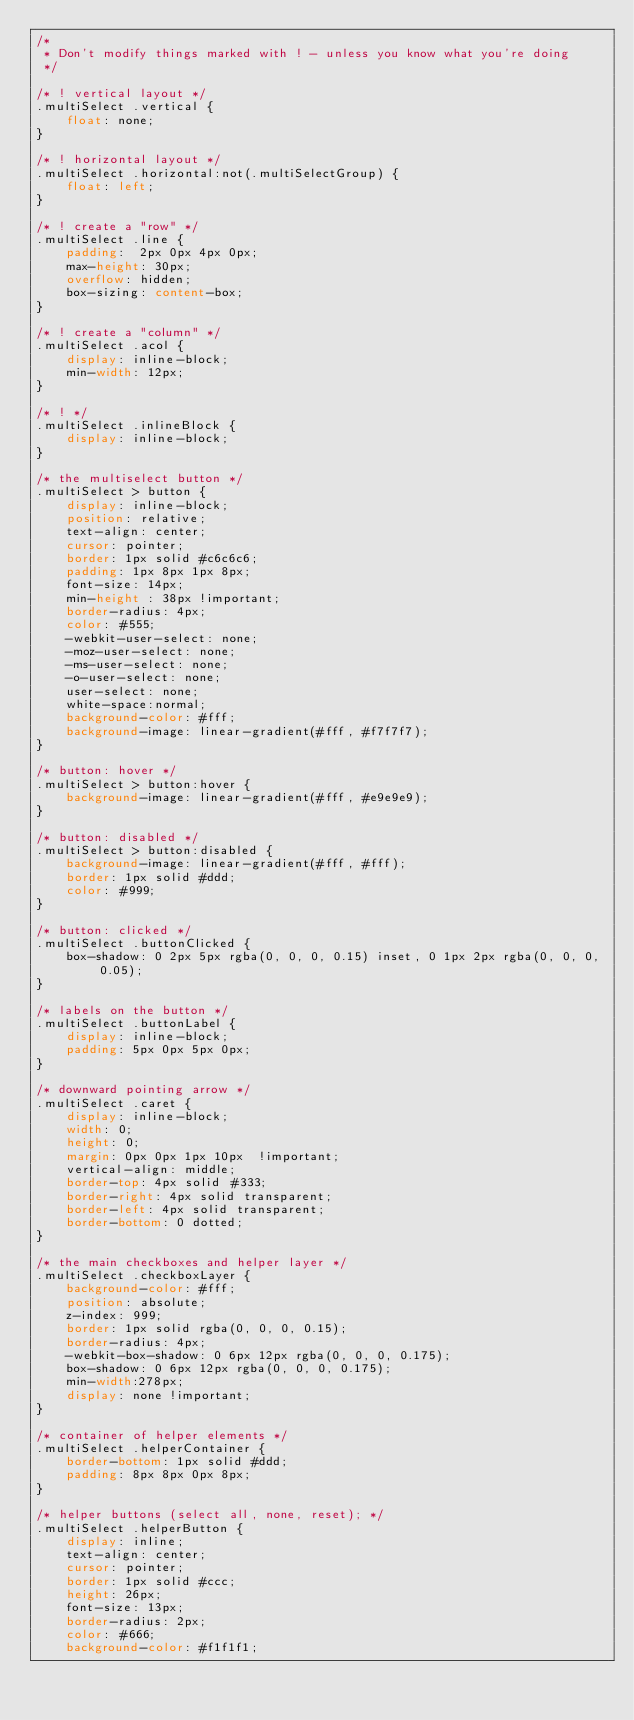<code> <loc_0><loc_0><loc_500><loc_500><_CSS_>/* 
 * Don't modify things marked with ! - unless you know what you're doing
 */

/* ! vertical layout */
.multiSelect .vertical {
    float: none;        
}

/* ! horizontal layout */
.multiSelect .horizontal:not(.multiSelectGroup) {
    float: left;
}

/* ! create a "row" */
.multiSelect .line {
    padding:  2px 0px 4px 0px;
    max-height: 30px;   
    overflow: hidden;
    box-sizing: content-box;
}

/* ! create a "column" */
.multiSelect .acol {
    display: inline-block;    
    min-width: 12px;
}

/* ! */
.multiSelect .inlineBlock {
    display: inline-block;
}

/* the multiselect button */
.multiSelect > button {
    display: inline-block;
    position: relative;
    text-align: center;    
    cursor: pointer;
    border: 1px solid #c6c6c6;    
    padding: 1px 8px 1px 8px;
    font-size: 14px;
    min-height : 38px !important;
    border-radius: 4px;
    color: #555;   
    -webkit-user-select: none;
    -moz-user-select: none;
    -ms-user-select: none;
    -o-user-select: none;
    user-select: none; 
    white-space:normal;
    background-color: #fff;
    background-image: linear-gradient(#fff, #f7f7f7);      
}

/* button: hover */
.multiSelect > button:hover {    
    background-image: linear-gradient(#fff, #e9e9e9);    
}

/* button: disabled */
.multiSelect > button:disabled {
    background-image: linear-gradient(#fff, #fff);      
    border: 1px solid #ddd;    
    color: #999;
}

/* button: clicked */
.multiSelect .buttonClicked {
    box-shadow: 0 2px 5px rgba(0, 0, 0, 0.15) inset, 0 1px 2px rgba(0, 0, 0, 0.05);
}

/* labels on the button */
.multiSelect .buttonLabel {
    display: inline-block;
    padding: 5px 0px 5px 0px;
}

/* downward pointing arrow */
.multiSelect .caret {
    display: inline-block;
    width: 0;
    height: 0;
    margin: 0px 0px 1px 10px  !important;
    vertical-align: middle;
    border-top: 4px solid #333;
    border-right: 4px solid transparent;
    border-left: 4px solid transparent;
    border-bottom: 0 dotted;
}

/* the main checkboxes and helper layer */
.multiSelect .checkboxLayer {
    background-color: #fff;
    position: absolute;
    z-index: 999;
    border: 1px solid rgba(0, 0, 0, 0.15);
    border-radius: 4px;
    -webkit-box-shadow: 0 6px 12px rgba(0, 0, 0, 0.175);
    box-shadow: 0 6px 12px rgba(0, 0, 0, 0.175);    
    min-width:278px;
    display: none !important;    
}

/* container of helper elements */
.multiSelect .helperContainer {
    border-bottom: 1px solid #ddd;
    padding: 8px 8px 0px 8px;
}

/* helper buttons (select all, none, reset); */
.multiSelect .helperButton {
    display: inline;
    text-align: center;
    cursor: pointer;
    border: 1px solid #ccc;
    height: 26px;
    font-size: 13px;
    border-radius: 2px;
    color: #666;    
    background-color: #f1f1f1;</code> 